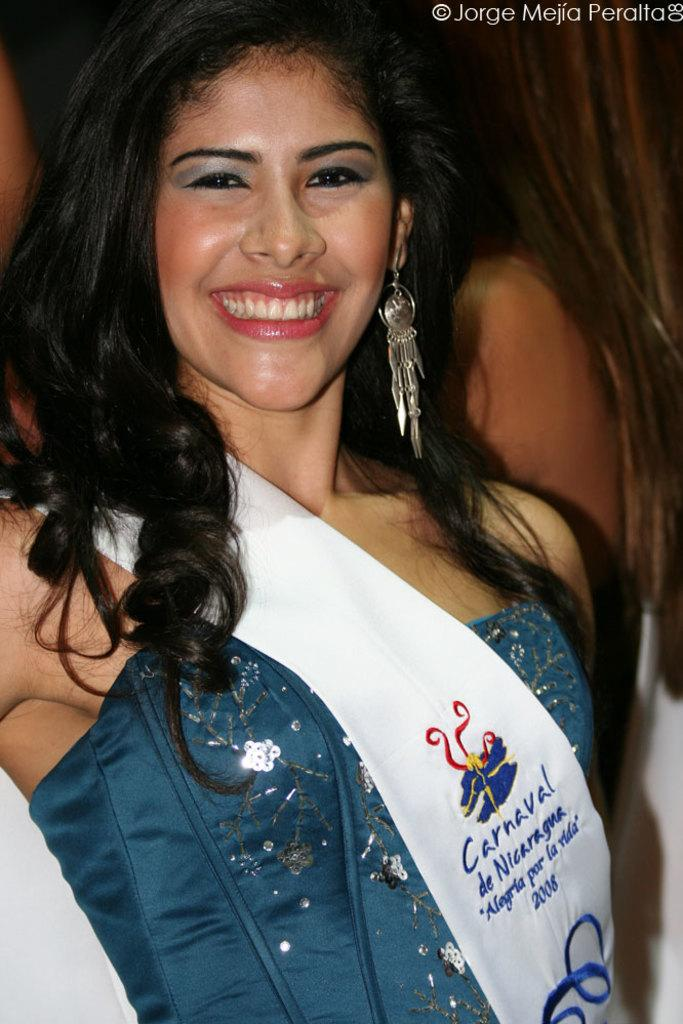Who is present in the image? There is a woman in the image. What is the woman wearing? The woman is wearing a blue dress and a white cloth. What type of quartz can be seen in the woman's hand in the image? There is no quartz present in the image; the woman is wearing a blue dress and a white cloth. How many tomatoes are visible on the woman's head in the image? There are no tomatoes present in the image; the woman is wearing a blue dress and a white cloth. 